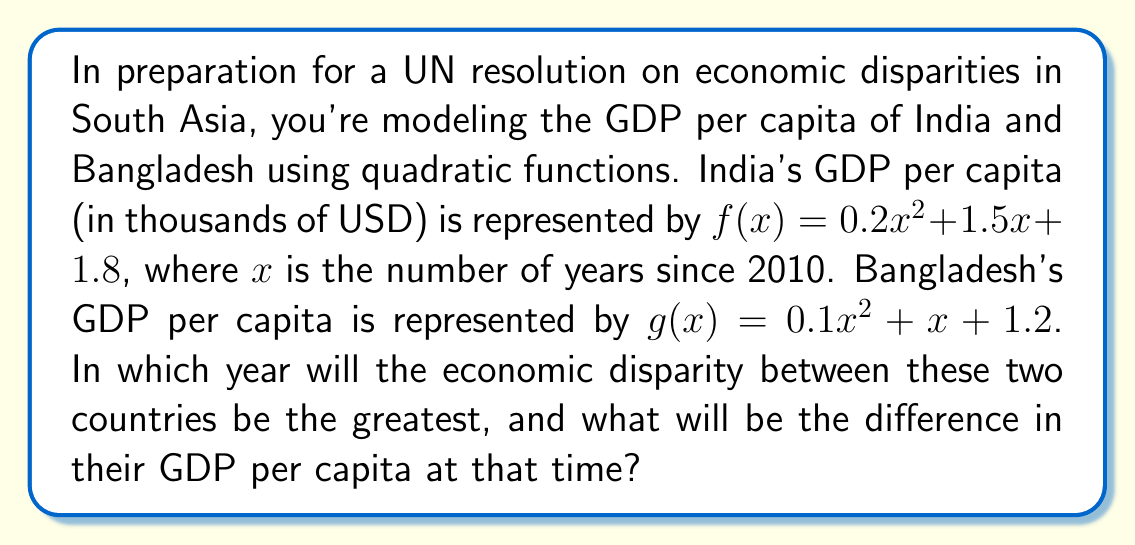Show me your answer to this math problem. 1) To find the maximum disparity, we need to maximize the difference between the two functions: $h(x) = f(x) - g(x)$

2) $h(x) = (0.2x^2 + 1.5x + 1.8) - (0.1x^2 + x + 1.2)$
         $= 0.1x^2 + 0.5x + 0.6$

3) To find the maximum of $h(x)$, we differentiate and set it to zero:
   $h'(x) = 0.2x + 0.5 = 0$

4) Solving for x:
   $0.2x = -0.5$
   $x = -2.5$

5) The second derivative $h''(x) = 0.2 > 0$, confirming this is a minimum, not a maximum.

6) Since $h(x)$ is a parabola opening upwards, and its axis of symmetry is at $x = -2.5$, the function will continue to increase as $x$ increases. The maximum disparity will occur at the latest year in our model.

7) Assuming we're modeling up to 2050, the maximum $x$ value would be 40 (2050 - 2010 = 40).

8) Calculate the GDP per capita for each country in 2050:
   India: $f(40) = 0.2(40)^2 + 1.5(40) + 1.8 = 380.8$
   Bangladesh: $g(40) = 0.1(40)^2 + 40 + 1.2 = 201.2$

9) The difference: $380.8 - 201.2 = 179.6$
Answer: 2050; $179,600 